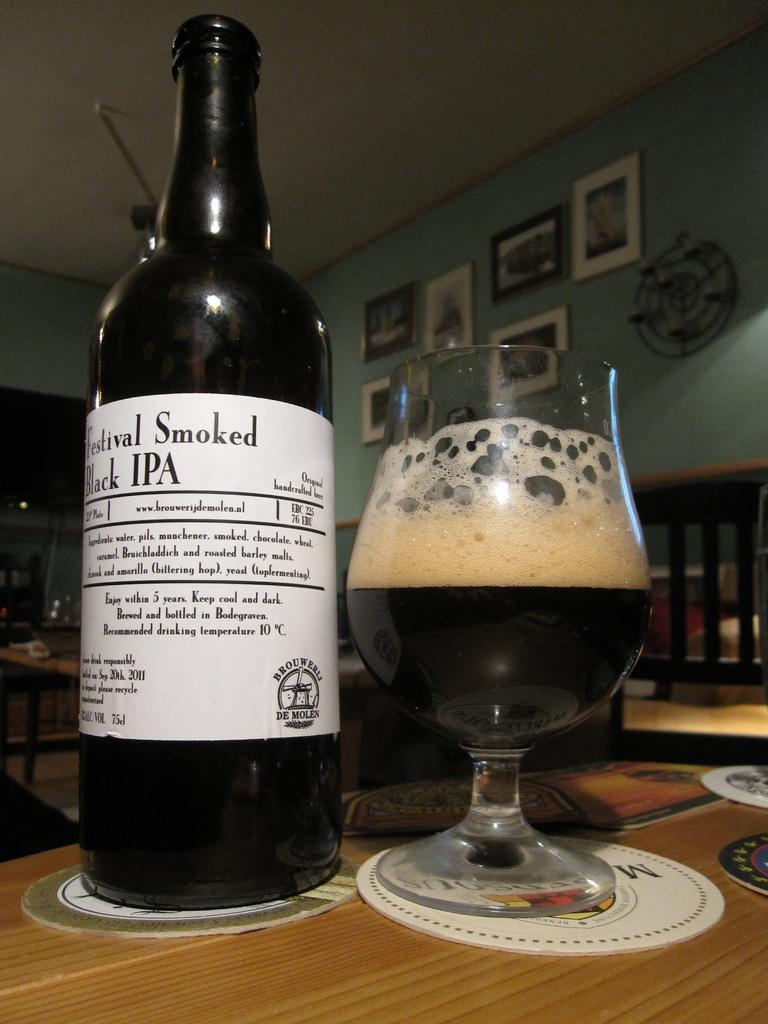<image>
Offer a succinct explanation of the picture presented. A half-drunk glass of beer is standing next to a bottle of Festival Smoked Black IPA 